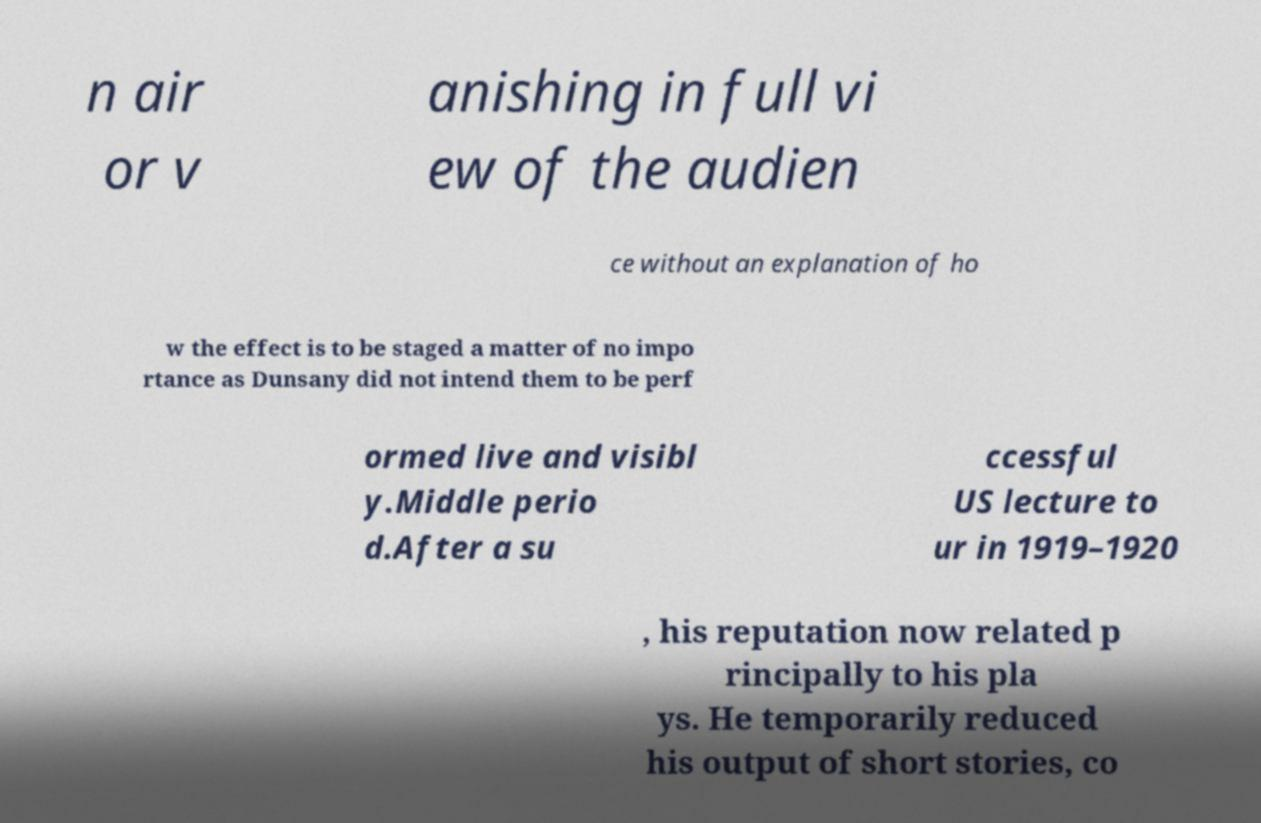There's text embedded in this image that I need extracted. Can you transcribe it verbatim? n air or v anishing in full vi ew of the audien ce without an explanation of ho w the effect is to be staged a matter of no impo rtance as Dunsany did not intend them to be perf ormed live and visibl y.Middle perio d.After a su ccessful US lecture to ur in 1919–1920 , his reputation now related p rincipally to his pla ys. He temporarily reduced his output of short stories, co 